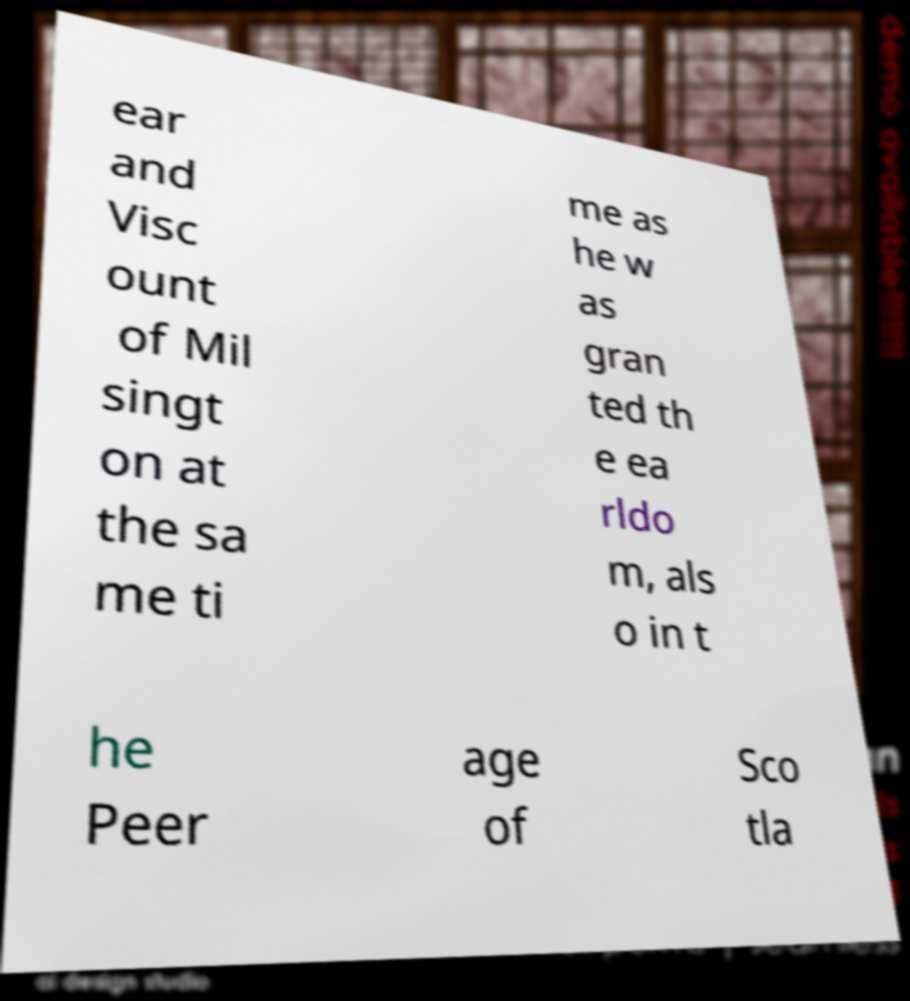Could you extract and type out the text from this image? ear and Visc ount of Mil singt on at the sa me ti me as he w as gran ted th e ea rldo m, als o in t he Peer age of Sco tla 